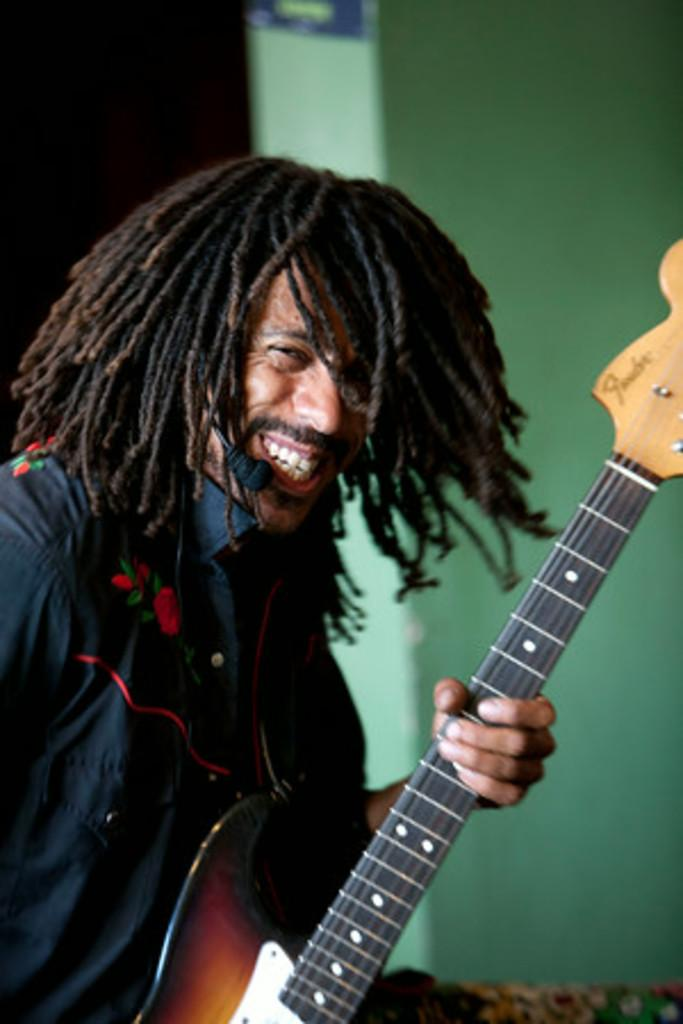What is the man in the image doing? The man is playing the guitar. What object does the man have to amplify his voice? The man has a microphone. How does the man appear to feel while playing the guitar? The man is smiling, which suggests he is enjoying himself. What type of metal is the guitar made of in the image? The facts provided do not mention the material of the guitar, so we cannot determine the type of metal it is made of. How does the man walk while playing the guitar in the image? The image does not show the man walking while playing the guitar; he is stationary. 